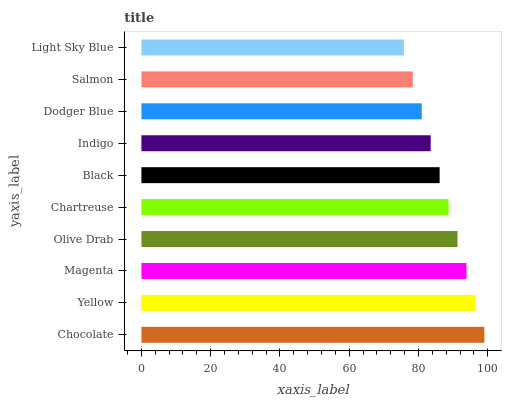Is Light Sky Blue the minimum?
Answer yes or no. Yes. Is Chocolate the maximum?
Answer yes or no. Yes. Is Yellow the minimum?
Answer yes or no. No. Is Yellow the maximum?
Answer yes or no. No. Is Chocolate greater than Yellow?
Answer yes or no. Yes. Is Yellow less than Chocolate?
Answer yes or no. Yes. Is Yellow greater than Chocolate?
Answer yes or no. No. Is Chocolate less than Yellow?
Answer yes or no. No. Is Chartreuse the high median?
Answer yes or no. Yes. Is Black the low median?
Answer yes or no. Yes. Is Salmon the high median?
Answer yes or no. No. Is Chartreuse the low median?
Answer yes or no. No. 